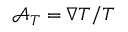<formula> <loc_0><loc_0><loc_500><loc_500>\mathcal { A } _ { T } = \nabla T / T</formula> 